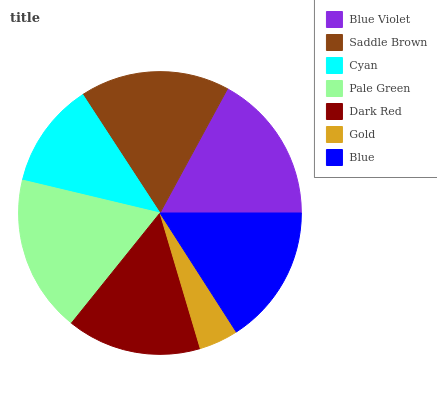Is Gold the minimum?
Answer yes or no. Yes. Is Pale Green the maximum?
Answer yes or no. Yes. Is Saddle Brown the minimum?
Answer yes or no. No. Is Saddle Brown the maximum?
Answer yes or no. No. Is Saddle Brown greater than Blue Violet?
Answer yes or no. Yes. Is Blue Violet less than Saddle Brown?
Answer yes or no. Yes. Is Blue Violet greater than Saddle Brown?
Answer yes or no. No. Is Saddle Brown less than Blue Violet?
Answer yes or no. No. Is Blue the high median?
Answer yes or no. Yes. Is Blue the low median?
Answer yes or no. Yes. Is Dark Red the high median?
Answer yes or no. No. Is Blue Violet the low median?
Answer yes or no. No. 